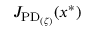<formula> <loc_0><loc_0><loc_500><loc_500>J _ { P D _ { ( \zeta ) } } ( x ^ { * } )</formula> 